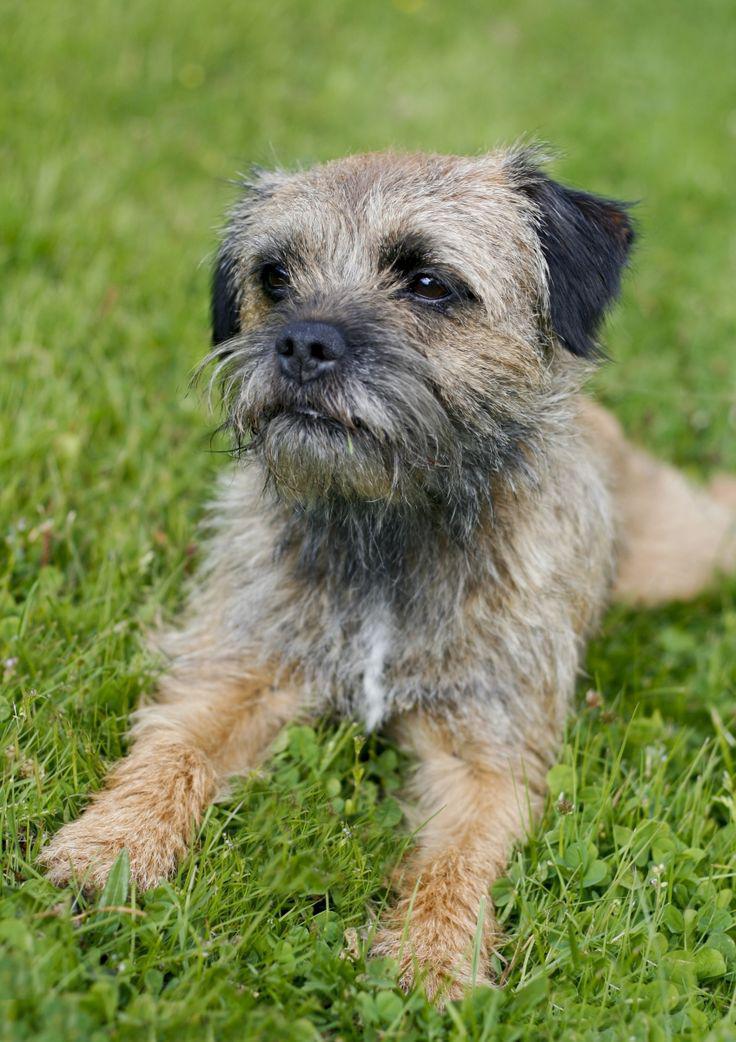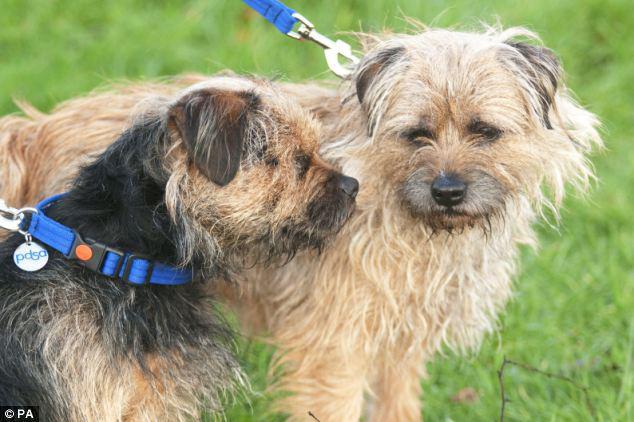The first image is the image on the left, the second image is the image on the right. Assess this claim about the two images: "All the dogs have a visible collar on.". Correct or not? Answer yes or no. No. The first image is the image on the left, the second image is the image on the right. Considering the images on both sides, is "a circular metal dog tag is attached to the dogs collar" valid? Answer yes or no. Yes. 